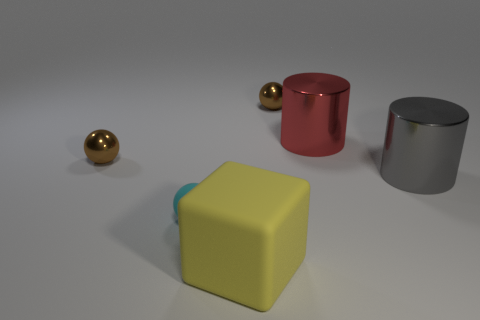What number of red cylinders have the same size as the cyan matte object?
Your answer should be very brief. 0. There is a brown metal object to the right of the yellow matte thing; is it the same size as the cyan sphere?
Your answer should be compact. Yes. What is the shape of the thing that is both on the right side of the yellow cube and on the left side of the red thing?
Provide a short and direct response. Sphere. Are there any brown metal spheres to the right of the yellow cube?
Offer a terse response. Yes. Are there any other things that have the same shape as the red metal object?
Provide a short and direct response. Yes. Is the shape of the large gray thing the same as the small cyan rubber object?
Keep it short and to the point. No. Is the number of things left of the rubber block the same as the number of big red cylinders left of the small cyan thing?
Give a very brief answer. No. What number of other objects are the same material as the big red thing?
Give a very brief answer. 3. How many tiny objects are either brown metal spheres or gray cylinders?
Your response must be concise. 2. Are there the same number of big cylinders in front of the large rubber thing and small cyan spheres?
Make the answer very short. No. 